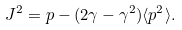Convert formula to latex. <formula><loc_0><loc_0><loc_500><loc_500>J ^ { 2 } = p - ( 2 \gamma - \gamma ^ { 2 } ) \langle p ^ { 2 } \rangle .</formula> 